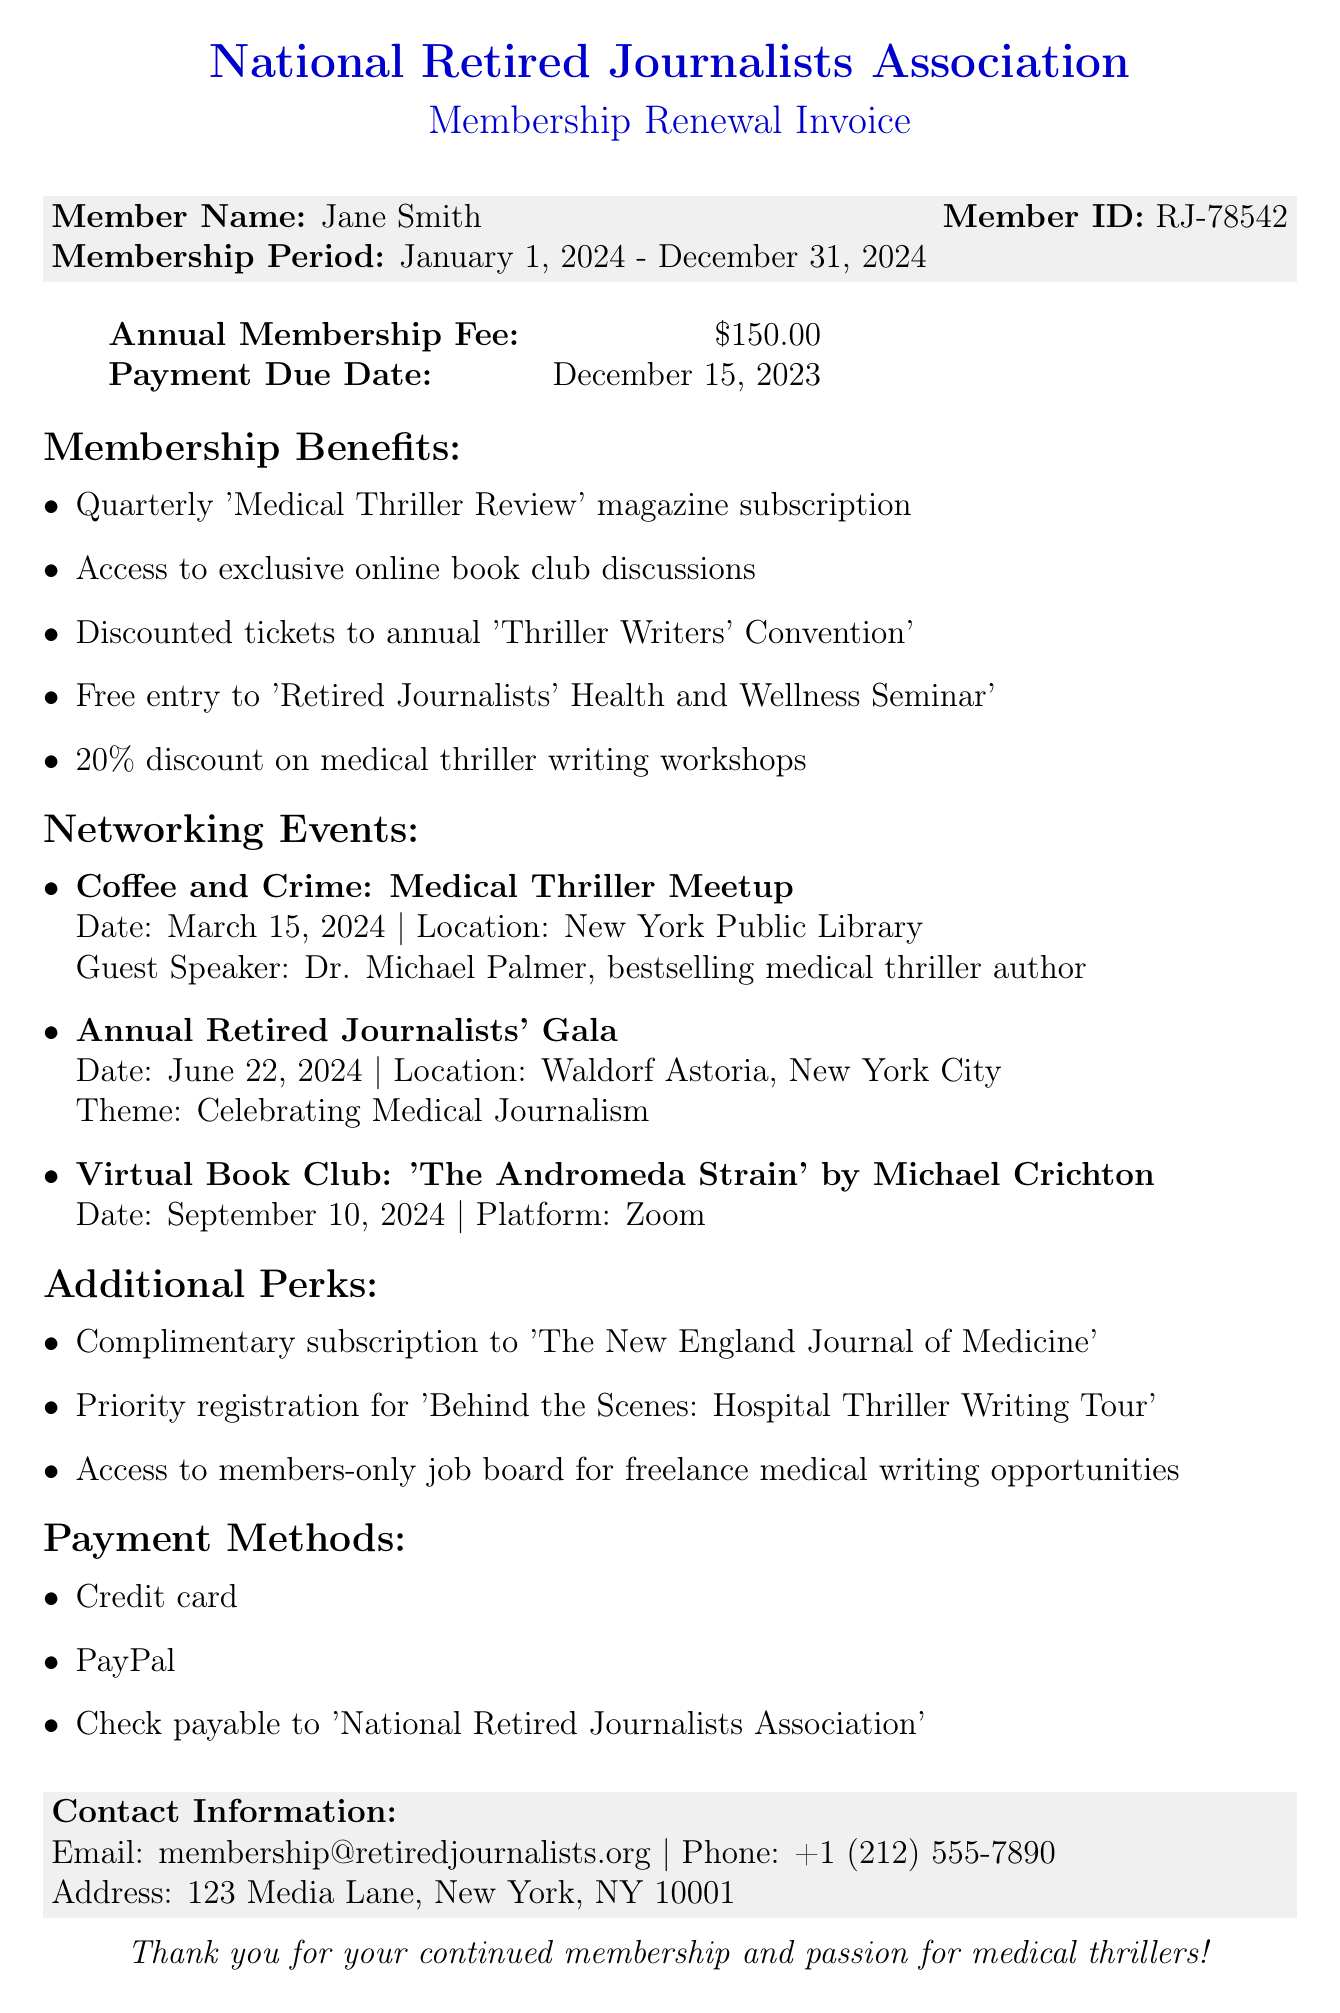What is the name of the association? The document states the association's name at the top as "National Retired Journalists Association."
Answer: National Retired Journalists Association What is the annual membership fee? The fee is specifically stated in the invoice section as $150.00.
Answer: $150.00 What is the payment due date? The document clearly mentions the payment due date as December 15, 2023.
Answer: December 15, 2023 What is one benefit included in the membership? A benefit is listed under membership benefits, such as a subscription to the 'Medical Thriller Review' magazine.
Answer: Quarterly 'Medical Thriller Review' magazine subscription How many networking events are mentioned? The invoice lists three specific networking events.
Answer: 3 Who is the guest speaker at the March 2024 event? The document names Dr. Michael Palmer as the guest speaker for the event on March 15, 2024.
Answer: Dr. Michael Palmer What additional perk provides a subscription to a medical journal? One of the additional perks is the complimentary subscription to 'The New England Journal of Medicine.'
Answer: Complimentary subscription to 'The New England Journal of Medicine' What payment methods are accepted? The document lists several payment methods including credit card, PayPal, and check.
Answer: Credit card, PayPal, Check What is the theme of the Annual Retired Journalists' Gala? The theme for the gala is stated as "Celebrating Medical Journalism."
Answer: Celebrating Medical Journalism 